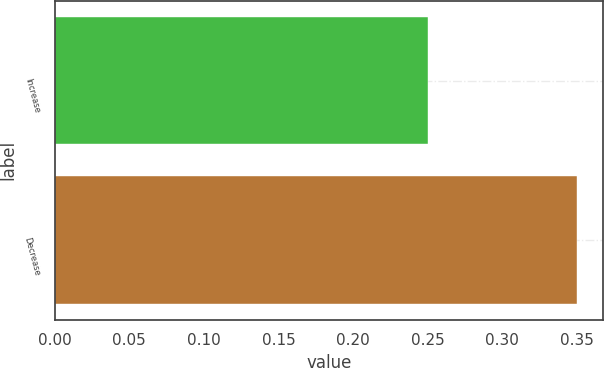<chart> <loc_0><loc_0><loc_500><loc_500><bar_chart><fcel>Increase<fcel>Decrease<nl><fcel>0.25<fcel>0.35<nl></chart> 